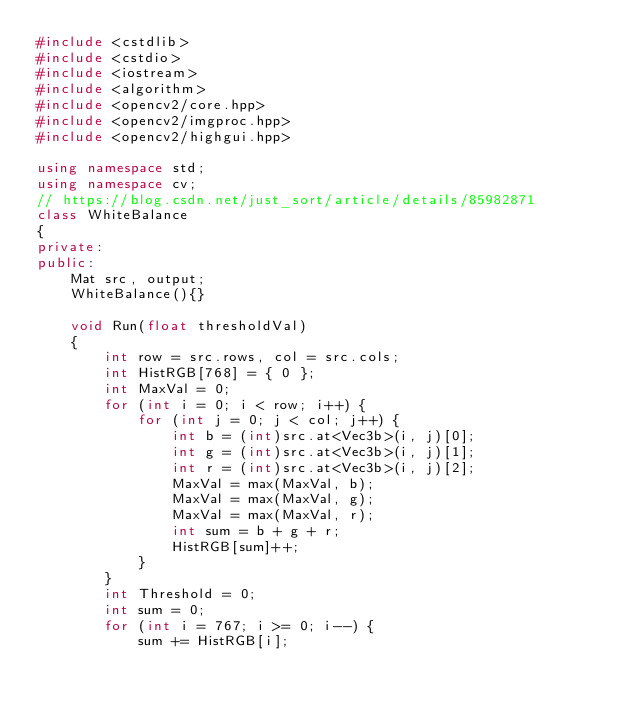Convert code to text. <code><loc_0><loc_0><loc_500><loc_500><_C++_>#include <cstdlib>
#include <cstdio>
#include <iostream>
#include <algorithm>
#include <opencv2/core.hpp>
#include <opencv2/imgproc.hpp>
#include <opencv2/highgui.hpp>

using namespace std;
using namespace cv;
// https://blog.csdn.net/just_sort/article/details/85982871
class WhiteBalance
{
private:
public:
	Mat src, output;
	WhiteBalance(){}

	void Run(float thresholdVal)
	{
		int row = src.rows, col = src.cols;
		int HistRGB[768] = { 0 };
		int MaxVal = 0;
		for (int i = 0; i < row; i++) {
			for (int j = 0; j < col; j++) {
				int b = (int)src.at<Vec3b>(i, j)[0];
				int g = (int)src.at<Vec3b>(i, j)[1];
				int r = (int)src.at<Vec3b>(i, j)[2];
				MaxVal = max(MaxVal, b);
				MaxVal = max(MaxVal, g);
				MaxVal = max(MaxVal, r);
				int sum = b + g + r;
				HistRGB[sum]++;
			}
		}
		int Threshold = 0;
		int sum = 0;
		for (int i = 767; i >= 0; i--) {
			sum += HistRGB[i];</code> 